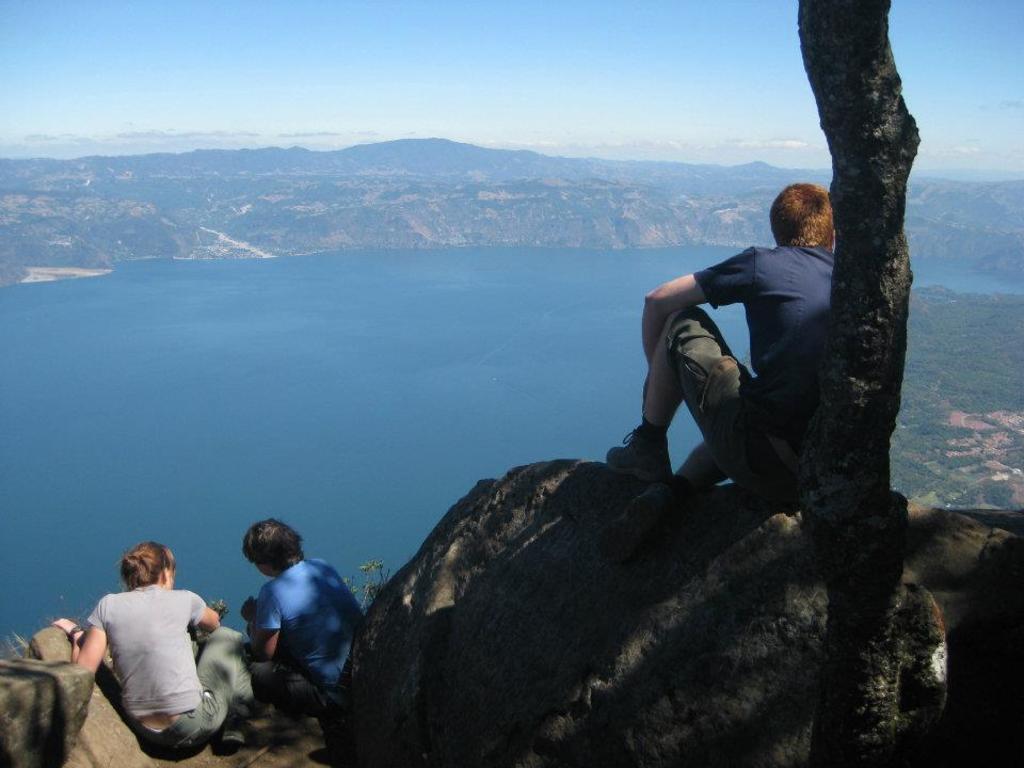Please provide a concise description of this image. There are three people sitting and we can see tree trunk. Background we can see water,hill and sky. 